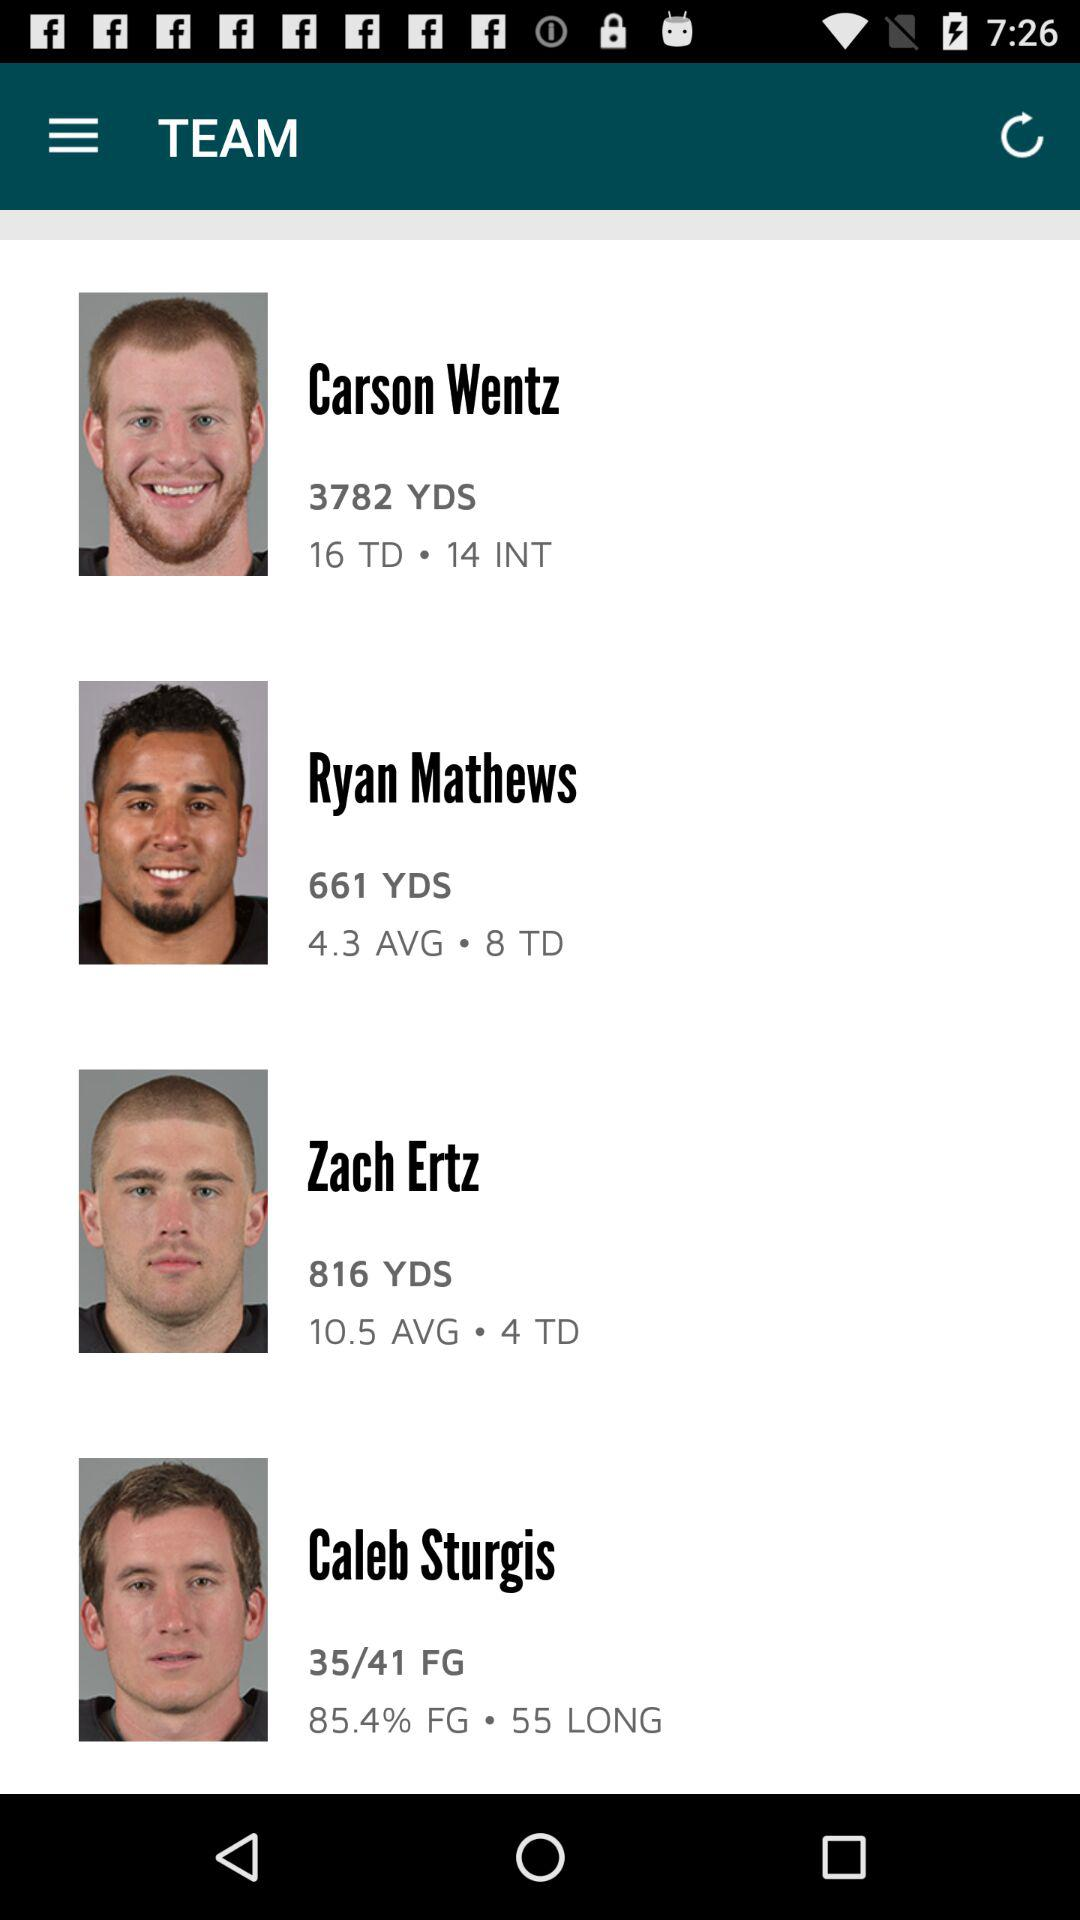How many more receiving yards does Zach Ertz have than Ryan Mathews?
Answer the question using a single word or phrase. 155 